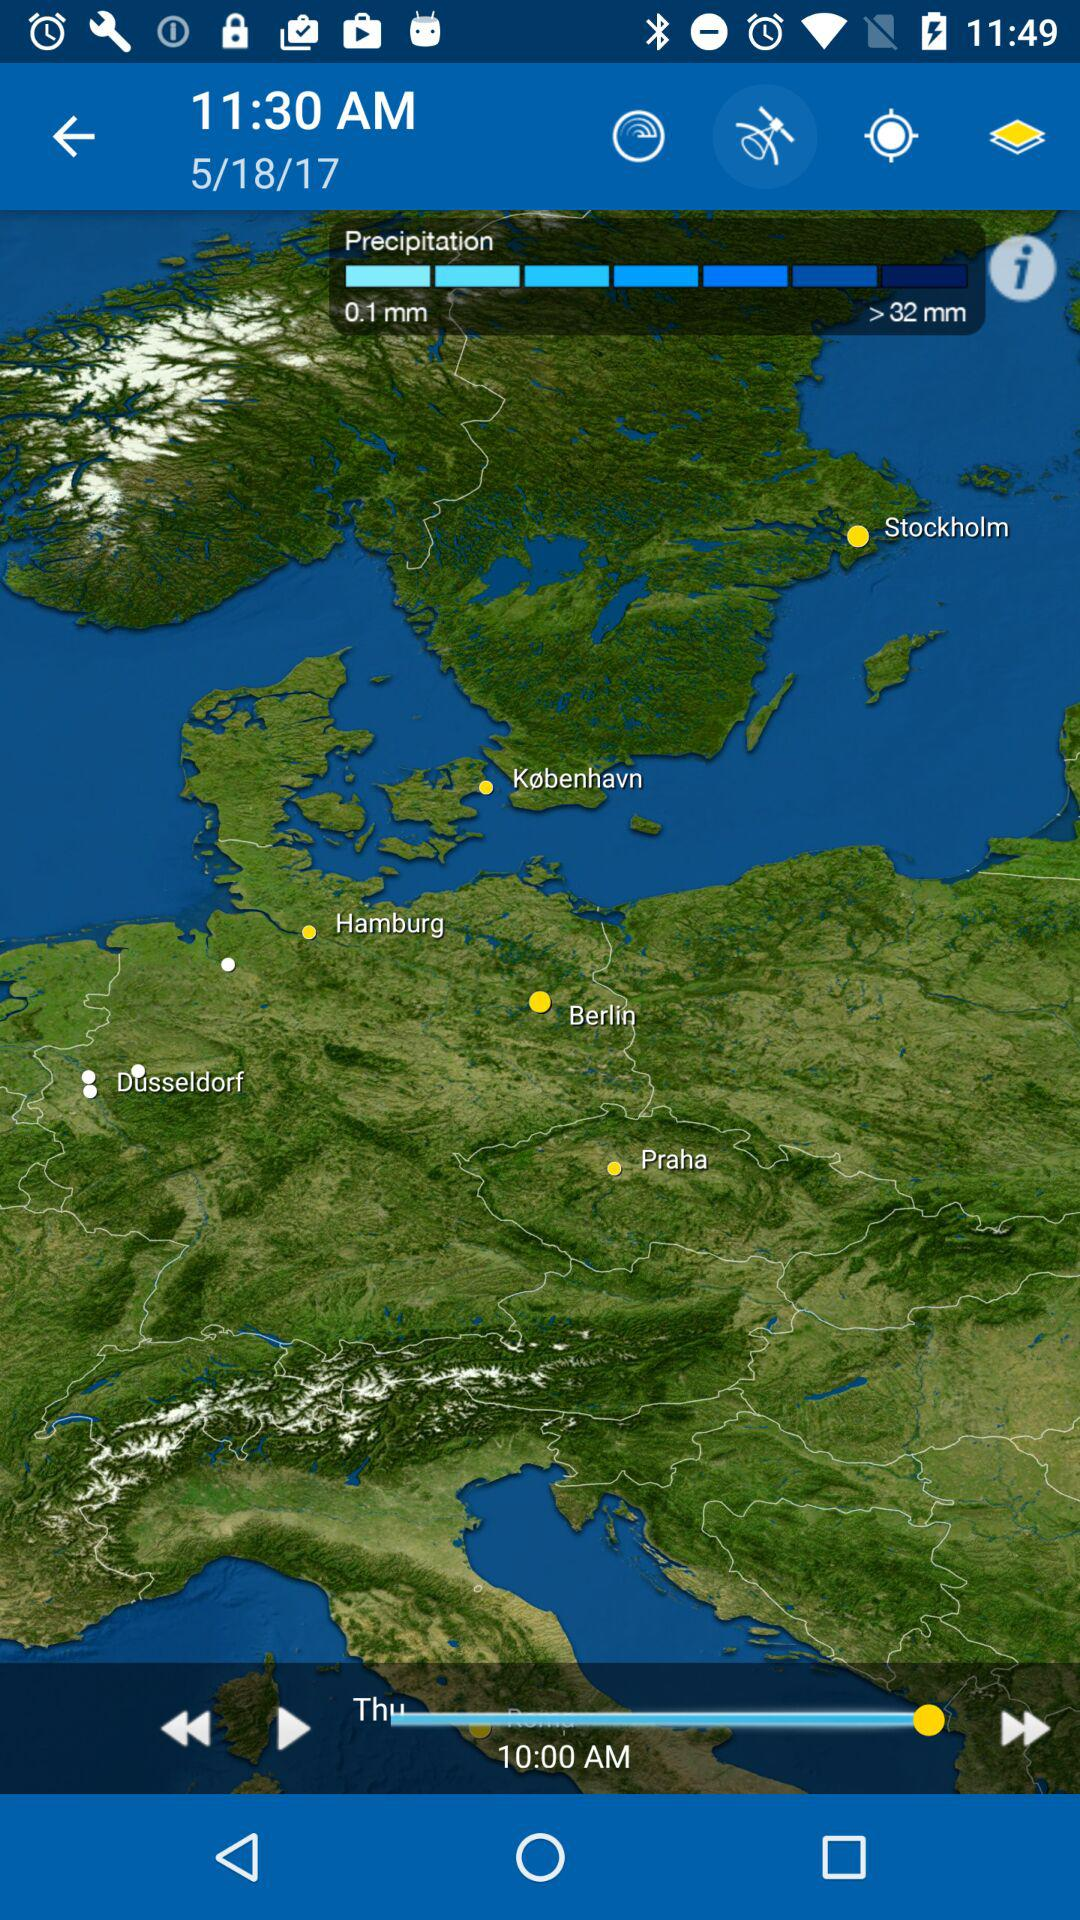What date and time are shown on the screen? The date and time are May 18, 2017 at 11:30 a.m. 